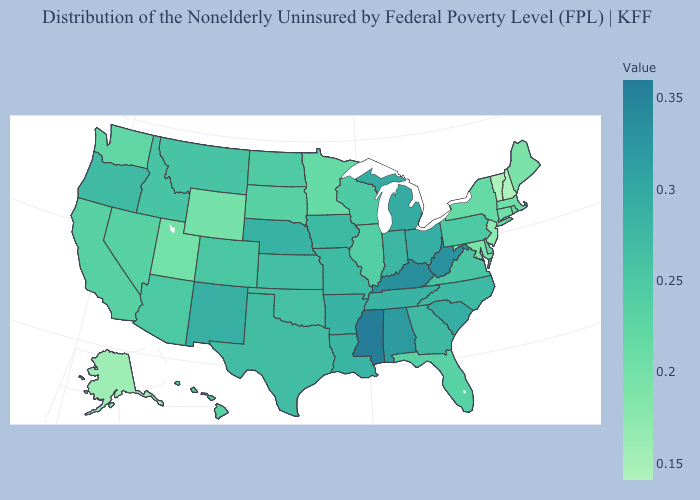Is the legend a continuous bar?
Give a very brief answer. Yes. Does Pennsylvania have the highest value in the Northeast?
Be succinct. Yes. Which states have the lowest value in the MidWest?
Quick response, please. Minnesota. Does Missouri have a higher value than Vermont?
Write a very short answer. Yes. 